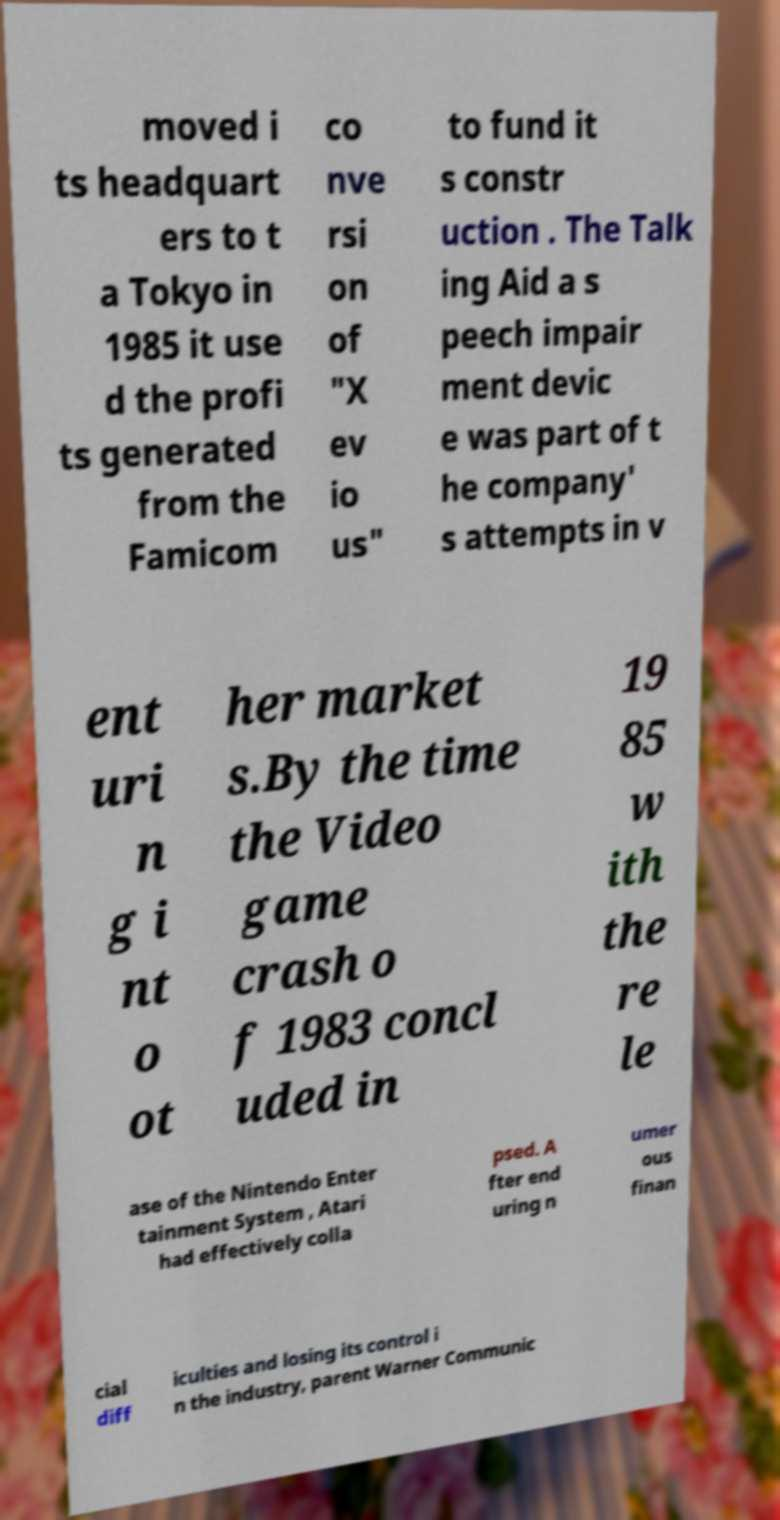There's text embedded in this image that I need extracted. Can you transcribe it verbatim? moved i ts headquart ers to t a Tokyo in 1985 it use d the profi ts generated from the Famicom co nve rsi on of "X ev io us" to fund it s constr uction . The Talk ing Aid a s peech impair ment devic e was part of t he company' s attempts in v ent uri n g i nt o ot her market s.By the time the Video game crash o f 1983 concl uded in 19 85 w ith the re le ase of the Nintendo Enter tainment System , Atari had effectively colla psed. A fter end uring n umer ous finan cial diff iculties and losing its control i n the industry, parent Warner Communic 